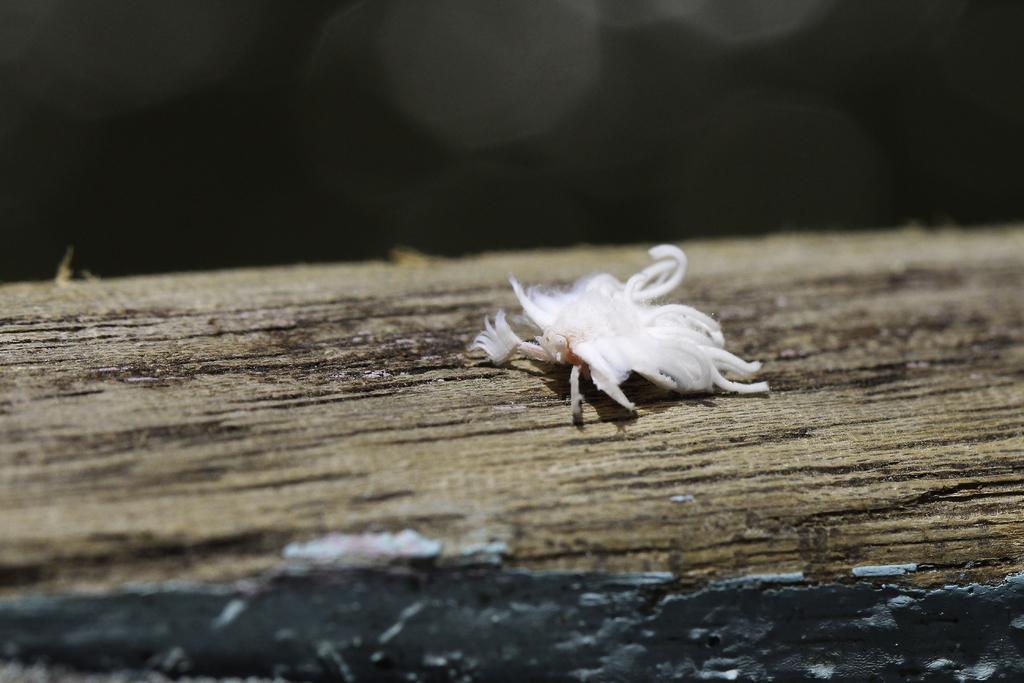Describe this image in one or two sentences. In this image, we can see a white color object is placed on the surface. Top of the image, we can see a blur view. 